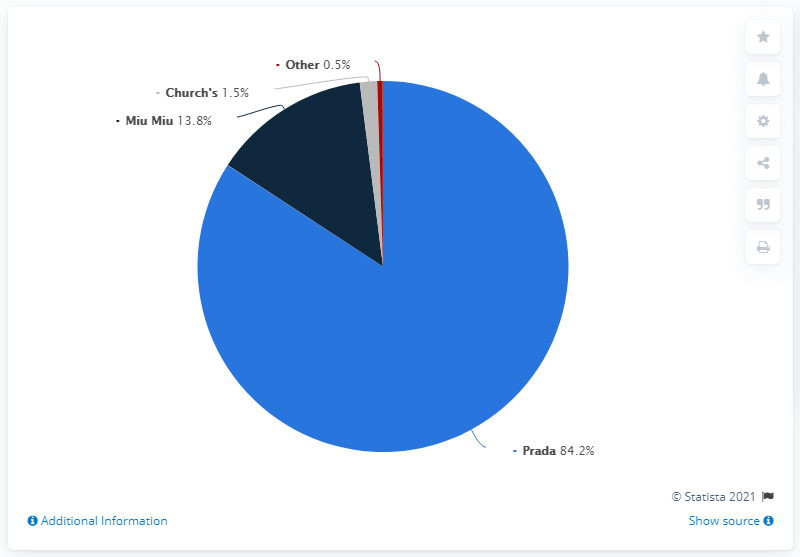Draw attention to some important aspects in this diagram. The sum of Miu Miu, Church's, and other is 15.8. In 2020, Miu Miu accounted for 13.8% of Prada's total sales. Prada was the brand that occupied almost the entire pie. 